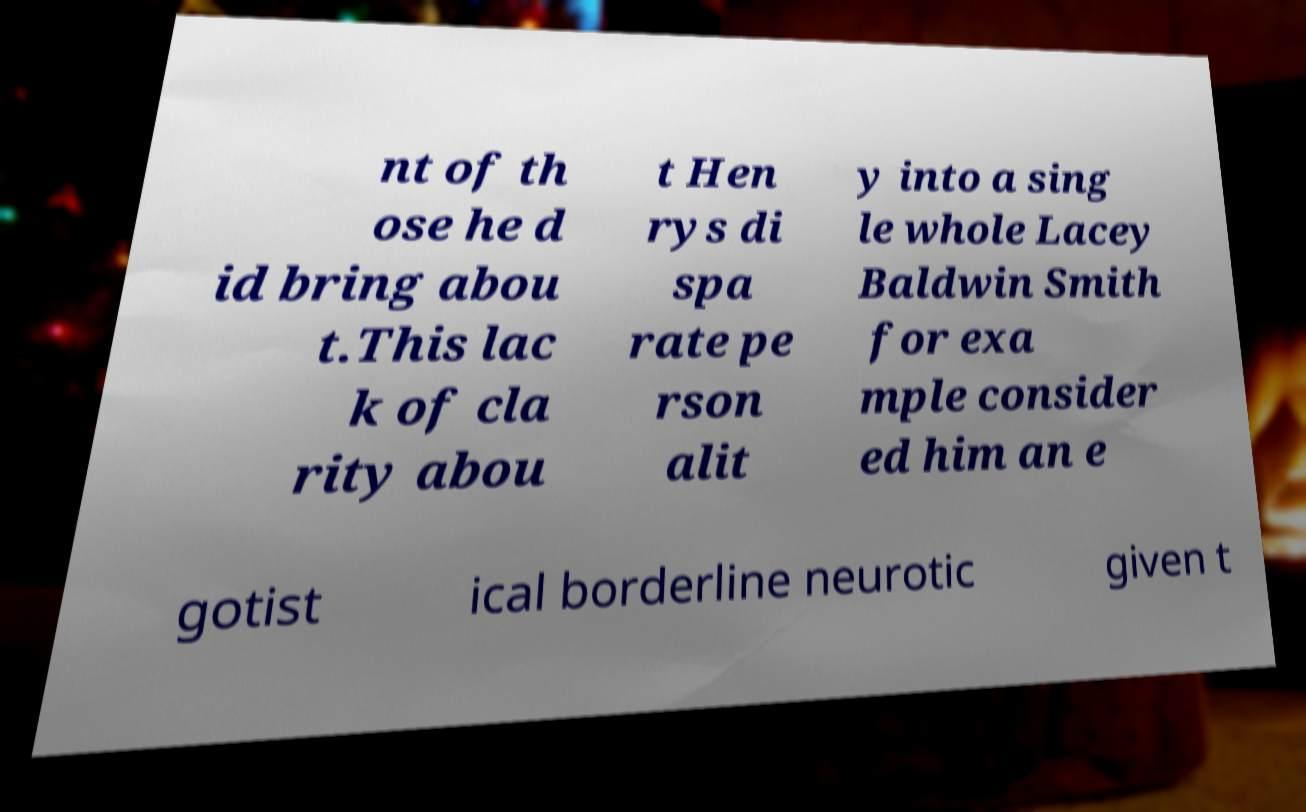Could you assist in decoding the text presented in this image and type it out clearly? nt of th ose he d id bring abou t.This lac k of cla rity abou t Hen rys di spa rate pe rson alit y into a sing le whole Lacey Baldwin Smith for exa mple consider ed him an e gotist ical borderline neurotic given t 